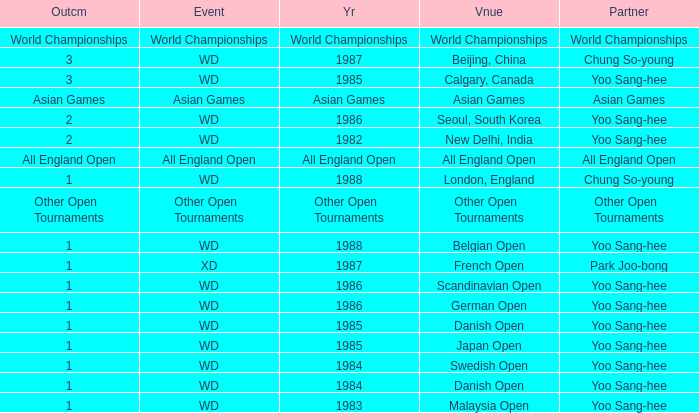In what Year did the German Open have Yoo Sang-Hee as Partner? 1986.0. 